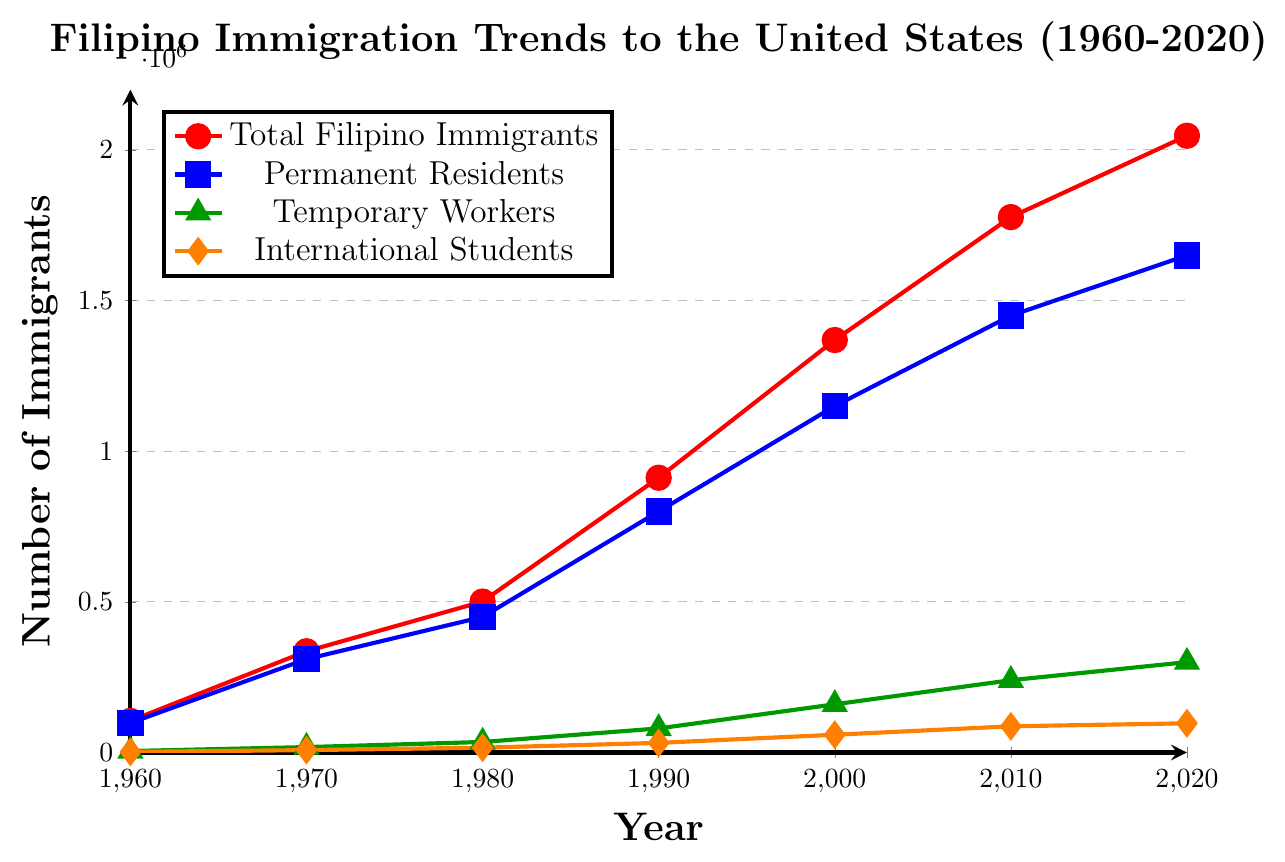What's the trend in the total number of Filipino immigrants to the United States from 1960 to 2020? The trend in the total number of Filipino immigrants to the United States increases steadily from 1960 to 2020, starting at 105,000 in 1960 and reaching 2,047,000 in 2020.
Answer: The number increases steadily Which year saw the largest increase in the number of permanent residents compared to the previous decade? To find the largest increase, calculate the differences for each decade: 310,000-98,000 = 212,000 (1970), 450,000-310,000 = 140,000 (1980), 800,000-450,000 = 350,000 (1990), 1,150,000-800,000 = 350,000 (2000), 1,450,000-1,150,000= 300,000 (2010), and 1,650,000-1,450,000= 200,000 (2020). 1990 and 2000 both have the largest increase of 350,000.
Answer: 1990 and 2000 By how much did the number of international students grow from 1960 to 2020? Subtract the number of international students in 1960 (2,000) from the number in 2020 (97,000): 97,000 - 2,000 = 95,000.
Answer: 95,000 Which group had the smallest increase in number between 2010 and 2020? The differences for each group are: Total Filipino Immigrants: 2047,000 - 1777,000 = 270,000; Permanent Residents: 1,650,000 - 1,450,000 = 200,000; Temporary Workers: 300,000 - 240,000 = 60,000; International Students: 97,000 - 87,000 = 10,000. The smallest increase is for International Students.
Answer: International Students What is the approximate ratio of Temporary Workers to Permanent Residents in 2020? Divide the number of Temporary Workers (300,000) by the number of Permanent Residents (1,650,000) in 2020: 300,000 / 1,650,000 ≈ 0.182.
Answer: 0.182 Which year had the smallest gap between the number of Temporary Workers and International Students? Calculate the gap for each year: 1960: 5,000 - 2,000 = 3,000; 1970: 18,000 - 8,000 = 10,000; 1980: 35,000 - 16,000 = 19,000; 1990: 80,000 - 32,000 = 48,000; 2000: 160,000 - 59,000 = 101,000; 2010: 240,000 - 87,000 = 153,000; 2020: 300,000 - 97,000 = 203,000. The smallest gap is in 1960.
Answer: 1960 Which group's number never decreased from one decade to the next? All groups must be checked. The totals for each group across all years show that none of the groups decreased from one decade to the next. The trends are consistently upward for all four groups.
Answer: All groups What's the increase percentage of total Filipino immigrants from 1960 to 2020? The increase is 2,047,000 - 105,000 = 1,942,000. The increase percentage is 1,942,000 / 105,000 * 100 ≈ 1849.5%.
Answer: 1849.5% How does the trend of Temporary Workers compare with that of International Students from 1960 to 2020? Both trends increase, but Temporary Workers grows more rapidly than International Students. Temporary Workers starts at 5,000 in 1960 and reaches 300,000 in 2020, whereas International Students starts at 2,000 in 1960 and reaches 97,000 in 2020.
Answer: Temporary Workers grow more rapidly What year did the total number of Filipino immigrants surpass one million? Look for the year when the total number exceeds one million: 1,369,000 in 2000.
Answer: 2000 